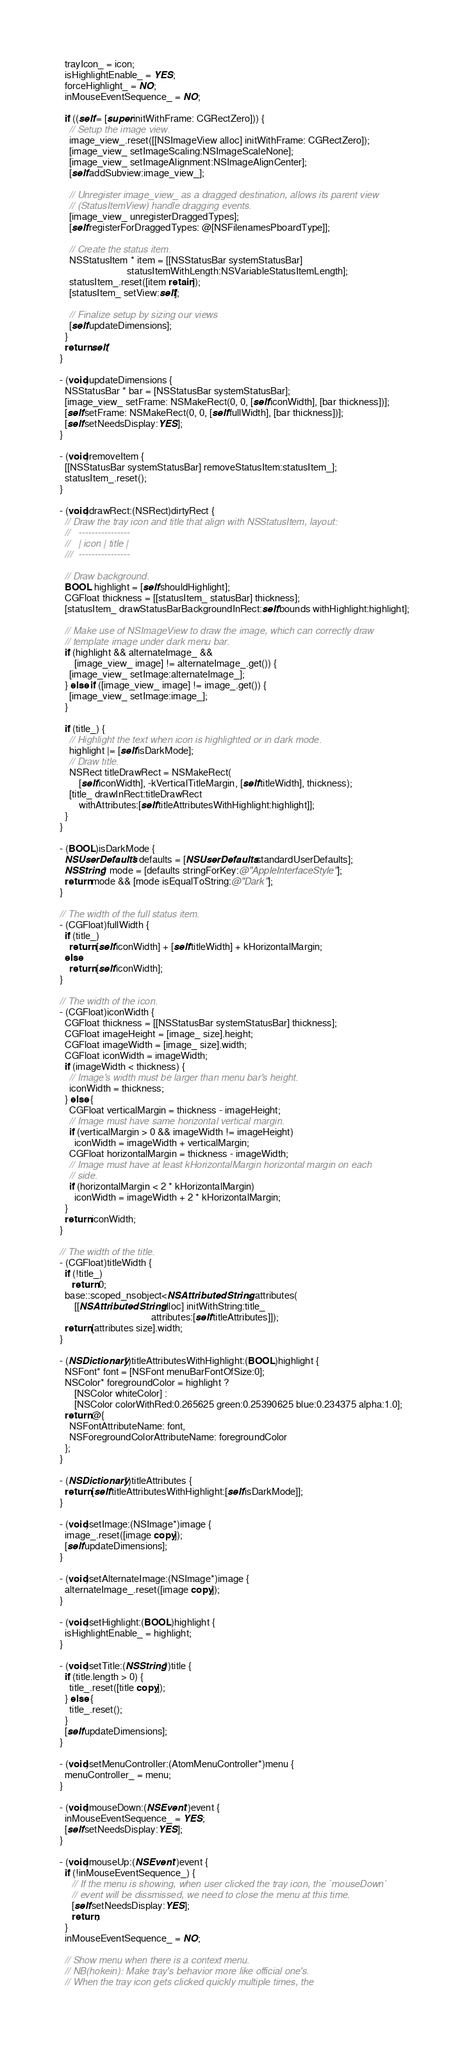Convert code to text. <code><loc_0><loc_0><loc_500><loc_500><_ObjectiveC_>  trayIcon_ = icon;
  isHighlightEnable_ = YES;
  forceHighlight_ = NO;
  inMouseEventSequence_ = NO;

  if ((self = [super initWithFrame: CGRectZero])) {
    // Setup the image view.
    image_view_.reset([[NSImageView alloc] initWithFrame: CGRectZero]);
    [image_view_ setImageScaling:NSImageScaleNone];
    [image_view_ setImageAlignment:NSImageAlignCenter];
    [self addSubview:image_view_];

    // Unregister image_view_ as a dragged destination, allows its parent view
    // (StatusItemView) handle dragging events.
    [image_view_ unregisterDraggedTypes];
    [self registerForDraggedTypes: @[NSFilenamesPboardType]];

    // Create the status item.
    NSStatusItem * item = [[NSStatusBar systemStatusBar]
                            statusItemWithLength:NSVariableStatusItemLength];
    statusItem_.reset([item retain]);
    [statusItem_ setView:self];

    // Finalize setup by sizing our views
    [self updateDimensions];
  }
  return self;
}

- (void)updateDimensions {
  NSStatusBar * bar = [NSStatusBar systemStatusBar];
  [image_view_ setFrame: NSMakeRect(0, 0, [self iconWidth], [bar thickness])];
  [self setFrame: NSMakeRect(0, 0, [self fullWidth], [bar thickness])];
  [self setNeedsDisplay:YES];
}

- (void)removeItem {
  [[NSStatusBar systemStatusBar] removeStatusItem:statusItem_];
  statusItem_.reset();
}

- (void)drawRect:(NSRect)dirtyRect {
  // Draw the tray icon and title that align with NSStatusItem, layout:
  //   ----------------
  //   | icon | title |
  ///  ----------------

  // Draw background.
  BOOL highlight = [self shouldHighlight];
  CGFloat thickness = [[statusItem_ statusBar] thickness];
  [statusItem_ drawStatusBarBackgroundInRect:self.bounds withHighlight:highlight];

  // Make use of NSImageView to draw the image, which can correctly draw
  // template image under dark menu bar.
  if (highlight && alternateImage_ &&
      [image_view_ image] != alternateImage_.get()) {
    [image_view_ setImage:alternateImage_];
  } else if ([image_view_ image] != image_.get()) {
    [image_view_ setImage:image_];
  }

  if (title_) {
    // Highlight the text when icon is highlighted or in dark mode.
    highlight |= [self isDarkMode];
    // Draw title.
    NSRect titleDrawRect = NSMakeRect(
        [self iconWidth], -kVerticalTitleMargin, [self titleWidth], thickness);
    [title_ drawInRect:titleDrawRect
        withAttributes:[self titleAttributesWithHighlight:highlight]];
  }
}

- (BOOL)isDarkMode {
  NSUserDefaults* defaults = [NSUserDefaults standardUserDefaults];
  NSString* mode = [defaults stringForKey:@"AppleInterfaceStyle"];
  return mode && [mode isEqualToString:@"Dark"];
}

// The width of the full status item.
- (CGFloat)fullWidth {
  if (title_)
    return [self iconWidth] + [self titleWidth] + kHorizontalMargin;
  else
    return [self iconWidth];
}

// The width of the icon.
- (CGFloat)iconWidth {
  CGFloat thickness = [[NSStatusBar systemStatusBar] thickness];
  CGFloat imageHeight = [image_ size].height;
  CGFloat imageWidth = [image_ size].width;
  CGFloat iconWidth = imageWidth;
  if (imageWidth < thickness) {
    // Image's width must be larger than menu bar's height.
    iconWidth = thickness;
  } else {
    CGFloat verticalMargin = thickness - imageHeight;
    // Image must have same horizontal vertical margin.
    if (verticalMargin > 0 && imageWidth != imageHeight)
      iconWidth = imageWidth + verticalMargin;
    CGFloat horizontalMargin = thickness - imageWidth;
    // Image must have at least kHorizontalMargin horizontal margin on each
    // side.
    if (horizontalMargin < 2 * kHorizontalMargin)
      iconWidth = imageWidth + 2 * kHorizontalMargin;
  }
  return iconWidth;
}

// The width of the title.
- (CGFloat)titleWidth {
  if (!title_)
     return 0;
  base::scoped_nsobject<NSAttributedString> attributes(
      [[NSAttributedString alloc] initWithString:title_
                                      attributes:[self titleAttributes]]);
  return [attributes size].width;
}

- (NSDictionary*)titleAttributesWithHighlight:(BOOL)highlight {
  NSFont* font = [NSFont menuBarFontOfSize:0];
  NSColor* foregroundColor = highlight ?
      [NSColor whiteColor] :
      [NSColor colorWithRed:0.265625 green:0.25390625 blue:0.234375 alpha:1.0];
  return @{
    NSFontAttributeName: font,
    NSForegroundColorAttributeName: foregroundColor
  };
}

- (NSDictionary*)titleAttributes {
  return [self titleAttributesWithHighlight:[self isDarkMode]];
}

- (void)setImage:(NSImage*)image {
  image_.reset([image copy]);
  [self updateDimensions];
}

- (void)setAlternateImage:(NSImage*)image {
  alternateImage_.reset([image copy]);
}

- (void)setHighlight:(BOOL)highlight {
  isHighlightEnable_ = highlight;
}

- (void)setTitle:(NSString*)title {
  if (title.length > 0) {
    title_.reset([title copy]);
  } else {
    title_.reset();
  }
  [self updateDimensions];
}

- (void)setMenuController:(AtomMenuController*)menu {
  menuController_ = menu;
}

- (void)mouseDown:(NSEvent*)event {
  inMouseEventSequence_ = YES;
  [self setNeedsDisplay:YES];
}

- (void)mouseUp:(NSEvent*)event {
  if (!inMouseEventSequence_) {
     // If the menu is showing, when user clicked the tray icon, the `mouseDown`
     // event will be dissmissed, we need to close the menu at this time.
     [self setNeedsDisplay:YES];
     return;
  }
  inMouseEventSequence_ = NO;

  // Show menu when there is a context menu.
  // NB(hokein): Make tray's behavior more like official one's.
  // When the tray icon gets clicked quickly multiple times, the</code> 